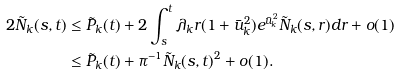Convert formula to latex. <formula><loc_0><loc_0><loc_500><loc_500>2 \tilde { N } _ { k } ( s , t ) & \leq \tilde { P } _ { k } ( t ) + 2 \int _ { s } ^ { t } \lambda _ { k } r ( 1 + \bar { u } _ { k } ^ { 2 } ) e ^ { \bar { u } _ { k } ^ { 2 } } \tilde { N } _ { k } ( s , r ) d r + o ( 1 ) \\ & \leq \tilde { P } _ { k } ( t ) + \pi ^ { - 1 } \tilde { N } _ { k } ( s , t ) ^ { 2 } + o ( 1 ) .</formula> 